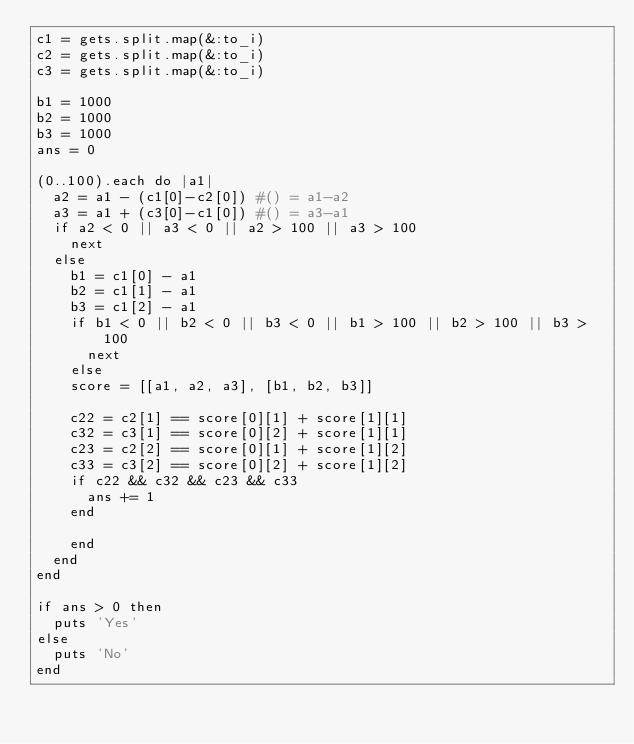<code> <loc_0><loc_0><loc_500><loc_500><_Ruby_>c1 = gets.split.map(&:to_i)
c2 = gets.split.map(&:to_i)
c3 = gets.split.map(&:to_i)

b1 = 1000
b2 = 1000
b3 = 1000
ans = 0

(0..100).each do |a1|
  a2 = a1 - (c1[0]-c2[0]) #() = a1-a2
  a3 = a1 + (c3[0]-c1[0]) #() = a3-a1
  if a2 < 0 || a3 < 0 || a2 > 100 || a3 > 100
    next
  else
    b1 = c1[0] - a1 
    b2 = c1[1] - a1
    b3 = c1[2] - a1
    if b1 < 0 || b2 < 0 || b3 < 0 || b1 > 100 || b2 > 100 || b3 > 100
      next
    else      
    score = [[a1, a2, a3], [b1, b2, b3]]
    
    c22 = c2[1] == score[0][1] + score[1][1]
    c32 = c3[1] == score[0][2] + score[1][1]
    c23 = c2[2] == score[0][1] + score[1][2]
    c33 = c3[2] == score[0][2] + score[1][2]
    if c22 && c32 && c23 && c33
      ans += 1
    end
      
    end  
  end
end

if ans > 0 then
  puts 'Yes'
else
  puts 'No'
end</code> 